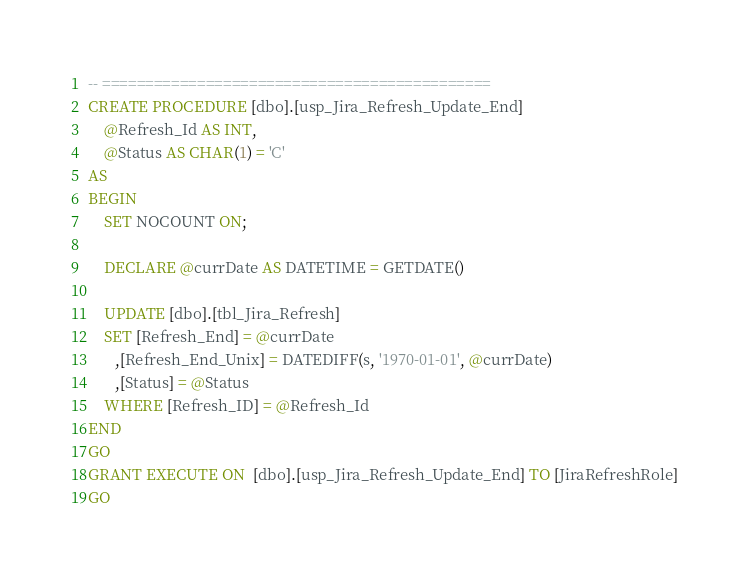Convert code to text. <code><loc_0><loc_0><loc_500><loc_500><_SQL_>-- =============================================
CREATE PROCEDURE [dbo].[usp_Jira_Refresh_Update_End]
	@Refresh_Id AS INT,
	@Status AS CHAR(1) = 'C'
AS
BEGIN
	SET NOCOUNT ON;

	DECLARE @currDate AS DATETIME = GETDATE()
    
	UPDATE [dbo].[tbl_Jira_Refresh]
	SET [Refresh_End] = @currDate
	   ,[Refresh_End_Unix] = DATEDIFF(s, '1970-01-01', @currDate)
	   ,[Status] = @Status
	WHERE [Refresh_ID] = @Refresh_Id
END
GO
GRANT EXECUTE ON  [dbo].[usp_Jira_Refresh_Update_End] TO [JiraRefreshRole]
GO
</code> 